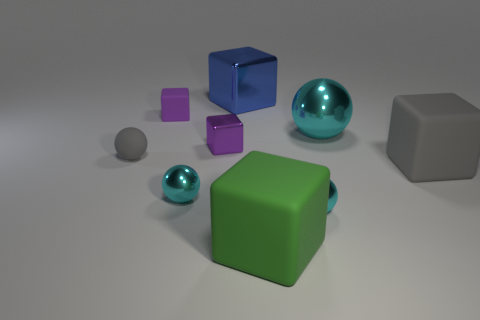Could you tell me which objects in the image appear to be made of metal? The objects in the image that have a metallic sheen are the two spheres—one large teal sphere and one smaller gray sphere. It is these reflective surfaces that give the impression of a metallic composition. 